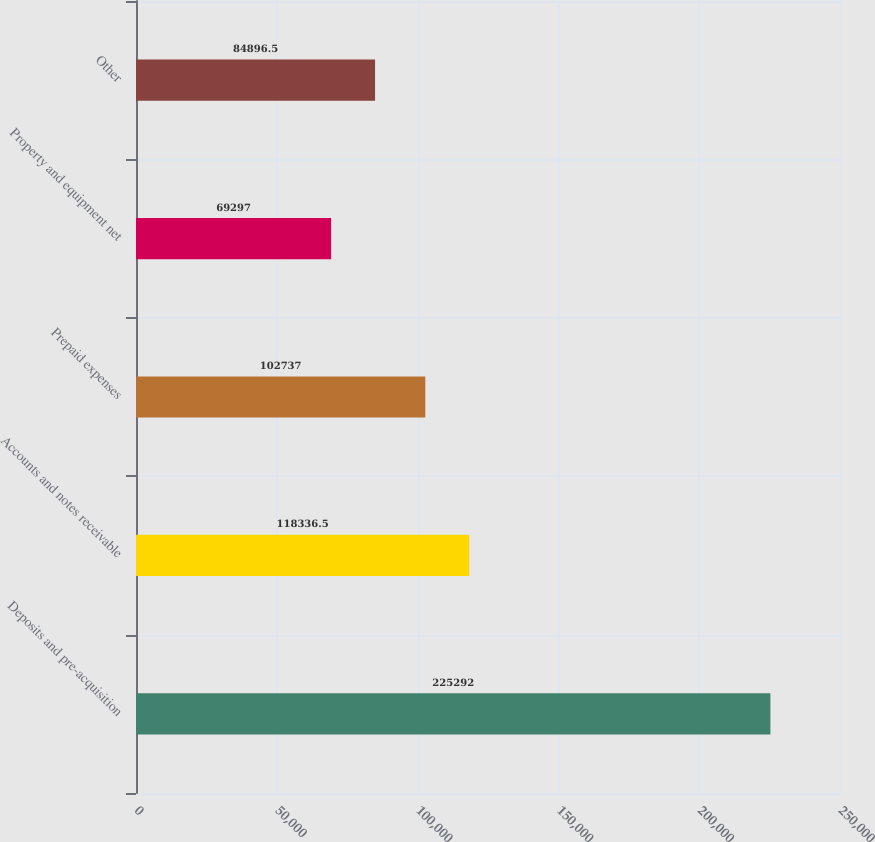Convert chart. <chart><loc_0><loc_0><loc_500><loc_500><bar_chart><fcel>Deposits and pre-acquisition<fcel>Accounts and notes receivable<fcel>Prepaid expenses<fcel>Property and equipment net<fcel>Other<nl><fcel>225292<fcel>118336<fcel>102737<fcel>69297<fcel>84896.5<nl></chart> 